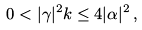<formula> <loc_0><loc_0><loc_500><loc_500>0 < | \gamma | ^ { 2 } k \leq 4 | \alpha | ^ { 2 } \, ,</formula> 